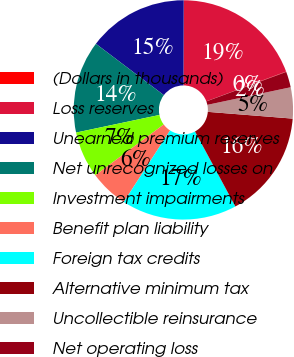<chart> <loc_0><loc_0><loc_500><loc_500><pie_chart><fcel>(Dollars in thousands)<fcel>Loss reserves<fcel>Unearned premium reserves<fcel>Net unrecognized losses on<fcel>Investment impairments<fcel>Benefit plan liability<fcel>Foreign tax credits<fcel>Alternative minimum tax<fcel>Uncollectible reinsurance<fcel>Net operating loss<nl><fcel>0.06%<fcel>19.27%<fcel>14.75%<fcel>13.62%<fcel>6.84%<fcel>5.71%<fcel>17.01%<fcel>15.88%<fcel>4.58%<fcel>2.32%<nl></chart> 